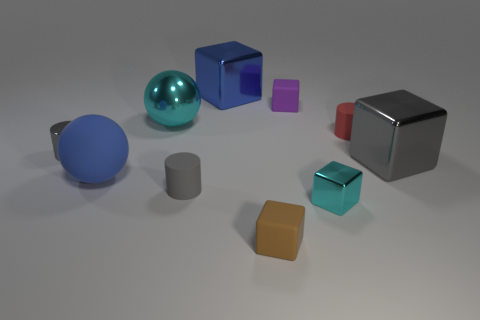There is a sphere that is the same material as the red object; what is its color?
Offer a terse response. Blue. Is the number of gray objects less than the number of rubber objects?
Provide a succinct answer. Yes. There is a gray thing that is both behind the blue matte object and right of the large blue rubber sphere; what is its material?
Your answer should be very brief. Metal. Is there a big blue cube in front of the tiny metal thing that is left of the big blue matte thing?
Your response must be concise. No. What number of small objects have the same color as the shiny cylinder?
Keep it short and to the point. 1. There is another tiny cylinder that is the same color as the metallic cylinder; what is its material?
Keep it short and to the point. Rubber. Is the material of the red cylinder the same as the big blue ball?
Offer a terse response. Yes. There is a tiny red thing; are there any cubes in front of it?
Offer a terse response. Yes. There is a big sphere behind the tiny rubber cylinder that is to the right of the tiny brown matte block; what is its material?
Provide a succinct answer. Metal. What is the size of the blue shiny object that is the same shape as the big gray object?
Your response must be concise. Large. 